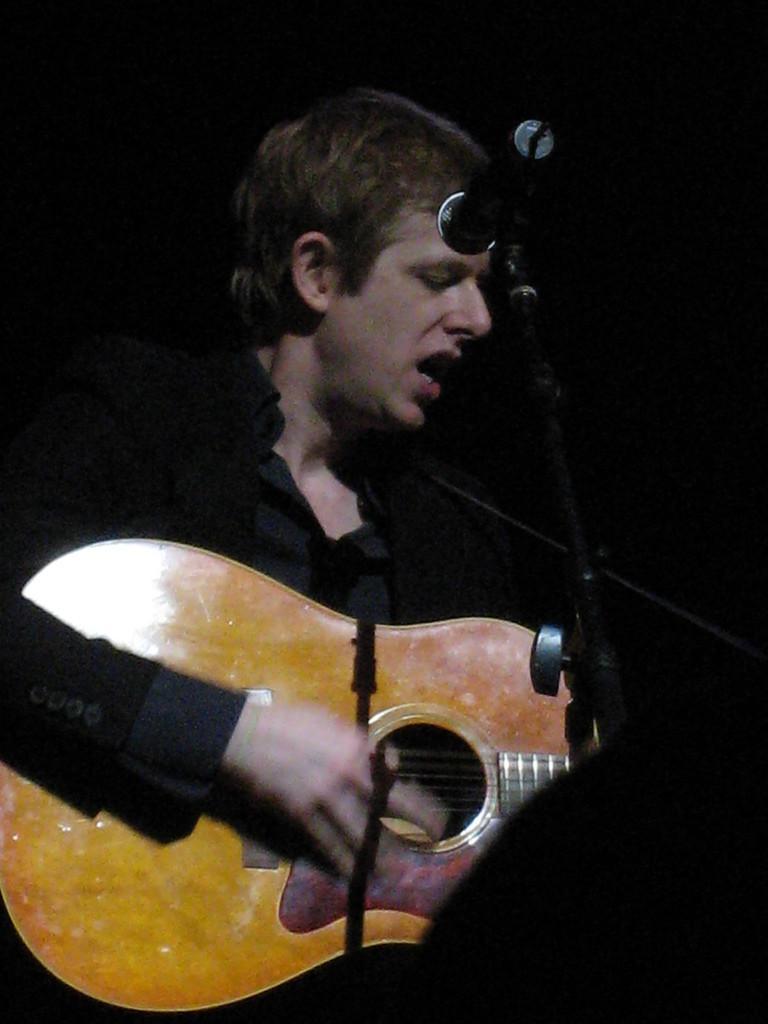In one or two sentences, can you explain what this image depicts? This is the picture of a person wearing black suit and holding the guitar and playing it front of the mic. 